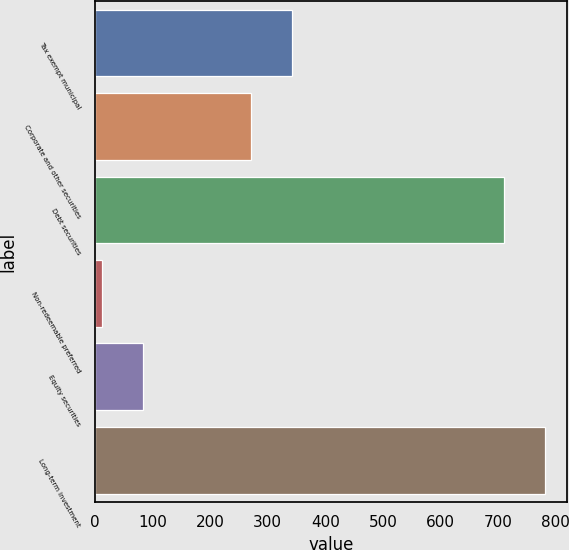Convert chart. <chart><loc_0><loc_0><loc_500><loc_500><bar_chart><fcel>Tax exempt municipal<fcel>Corporate and other securities<fcel>Debt securities<fcel>Non-redeemable preferred<fcel>Equity securities<fcel>Long-term investment<nl><fcel>342<fcel>271<fcel>710<fcel>13<fcel>84<fcel>781<nl></chart> 